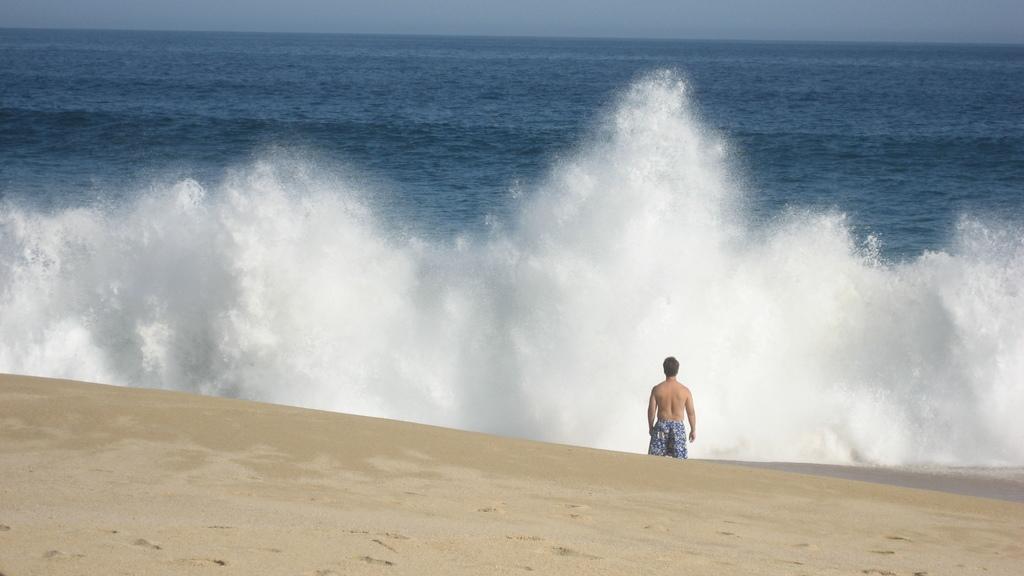Could you give a brief overview of what you see in this image? This image is clicked near the beach. In the front, there is a man standing. At the bottom, there is sand. In the middle, there are waves in the ocean. 